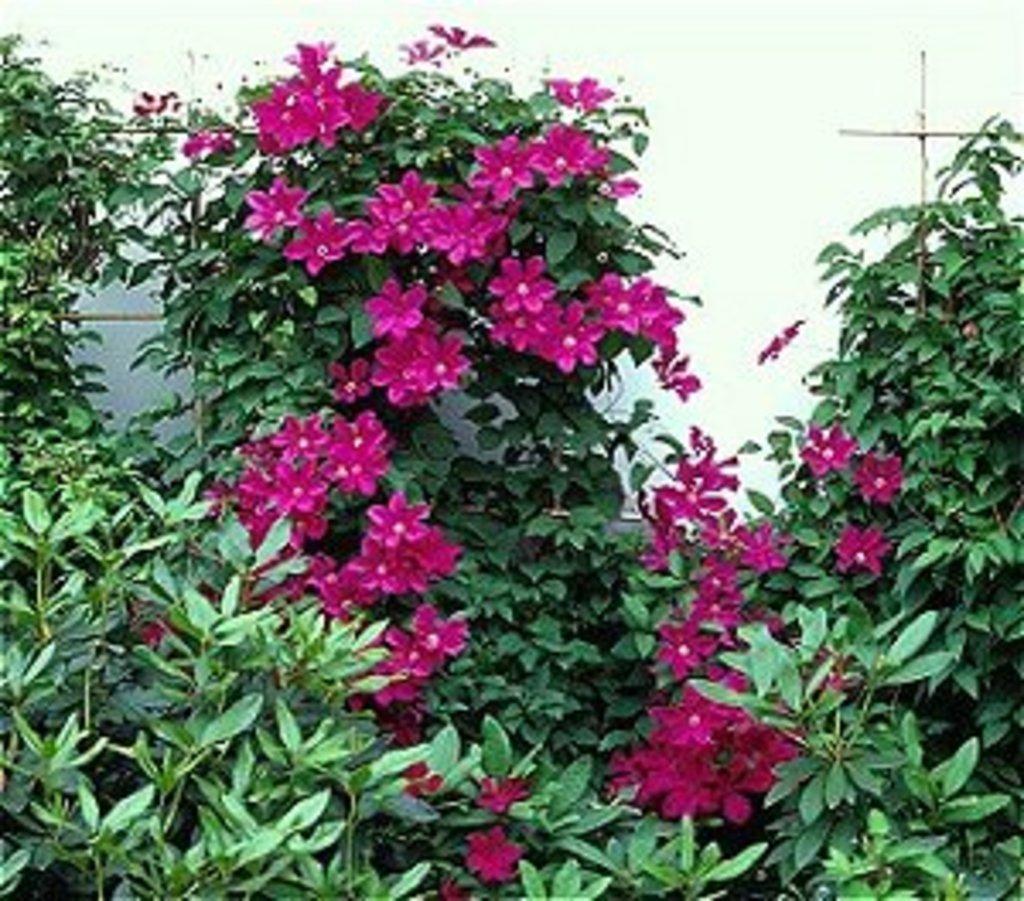Please provide a concise description of this image. In this picture we can see the flowers, leaves and stems. Background portion of the picture is blurry and few objects are visible. 